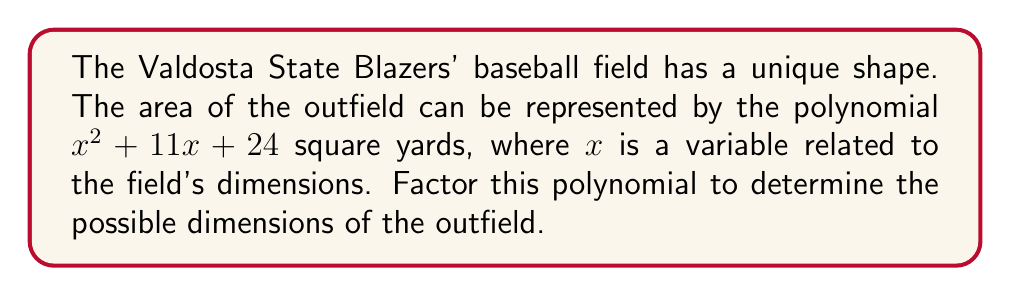Teach me how to tackle this problem. To factor the polynomial $x^2 + 11x + 24$, we'll follow these steps:

1) First, identify that this is a quadratic polynomial in the form $ax^2 + bx + c$, where $a=1$, $b=11$, and $c=24$.

2) We need to find two numbers that multiply to give $ac = 1 \times 24 = 24$ and add up to $b = 11$.

3) The factors of 24 are: 1, 2, 3, 4, 6, 8, 12, and 24.

4) By inspection, we can see that 3 and 8 multiply to give 24 and add up to 11.

5) We can rewrite the middle term using these numbers:
   $x^2 + 11x + 24 = x^2 + 3x + 8x + 24$

6) Now we can group the terms:
   $(x^2 + 3x) + (8x + 24)$

7) Factor out the common factors from each group:
   $x(x + 3) + 8(x + 3)$

8) We can now factor out the common binomial $(x + 3)$:
   $(x + 3)(x + 8)$

Therefore, the factored form of the polynomial is $(x + 3)(x + 8)$.

This means the possible dimensions of the outfield are $(x + 3)$ yards and $(x + 8)$ yards, where $x$ is some base measurement.
Answer: $(x + 3)(x + 8)$ 